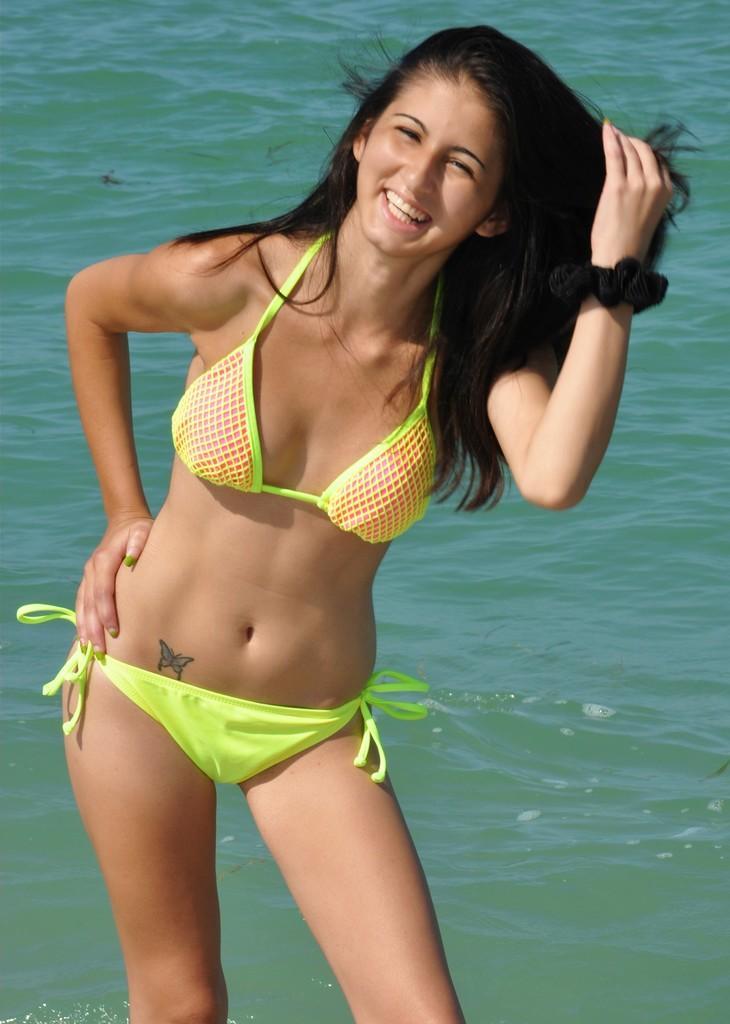Please provide a concise description of this image. This picture shows a woman standing in the water with a smile on her face. 